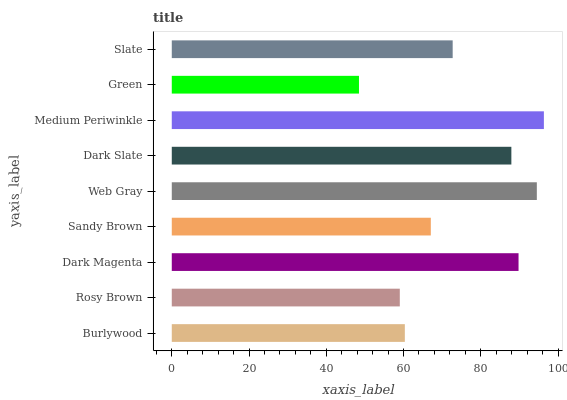Is Green the minimum?
Answer yes or no. Yes. Is Medium Periwinkle the maximum?
Answer yes or no. Yes. Is Rosy Brown the minimum?
Answer yes or no. No. Is Rosy Brown the maximum?
Answer yes or no. No. Is Burlywood greater than Rosy Brown?
Answer yes or no. Yes. Is Rosy Brown less than Burlywood?
Answer yes or no. Yes. Is Rosy Brown greater than Burlywood?
Answer yes or no. No. Is Burlywood less than Rosy Brown?
Answer yes or no. No. Is Slate the high median?
Answer yes or no. Yes. Is Slate the low median?
Answer yes or no. Yes. Is Medium Periwinkle the high median?
Answer yes or no. No. Is Web Gray the low median?
Answer yes or no. No. 